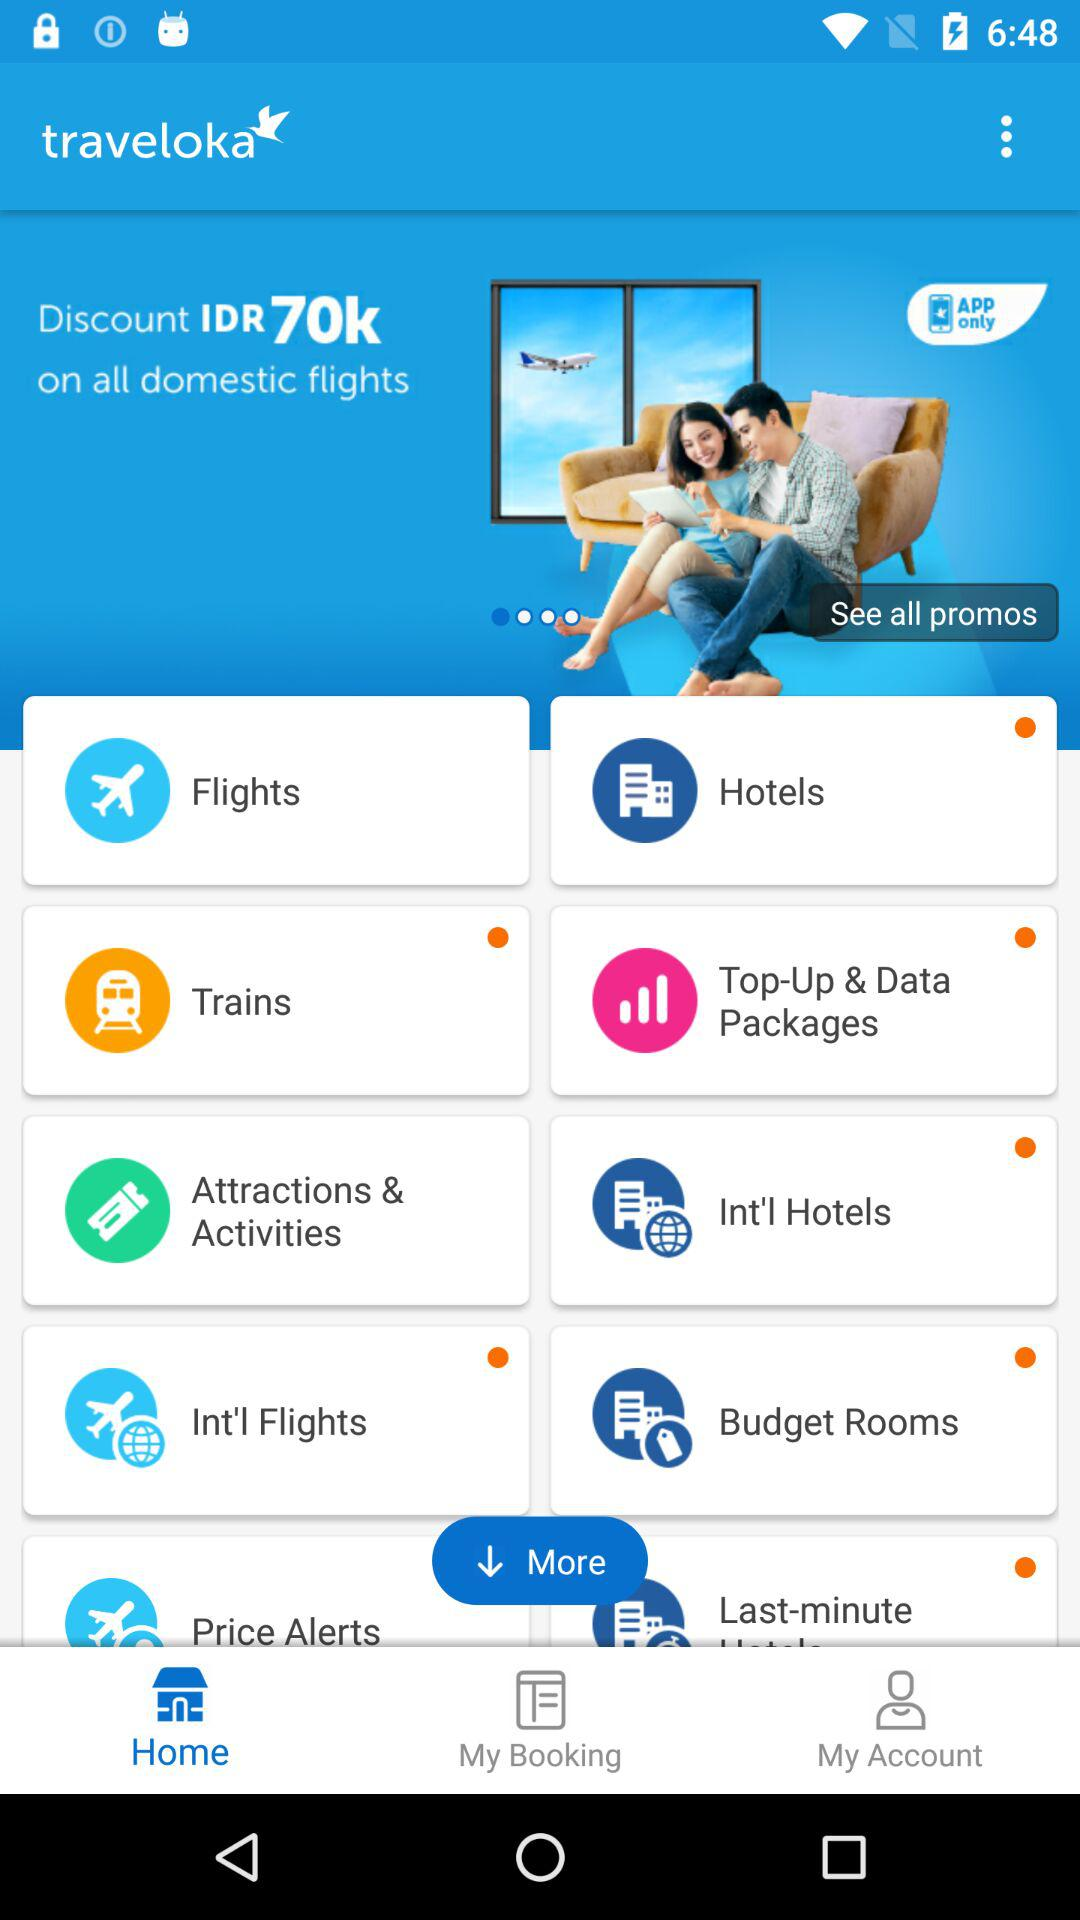Which is the selected tab? The selected tab is "Home". 